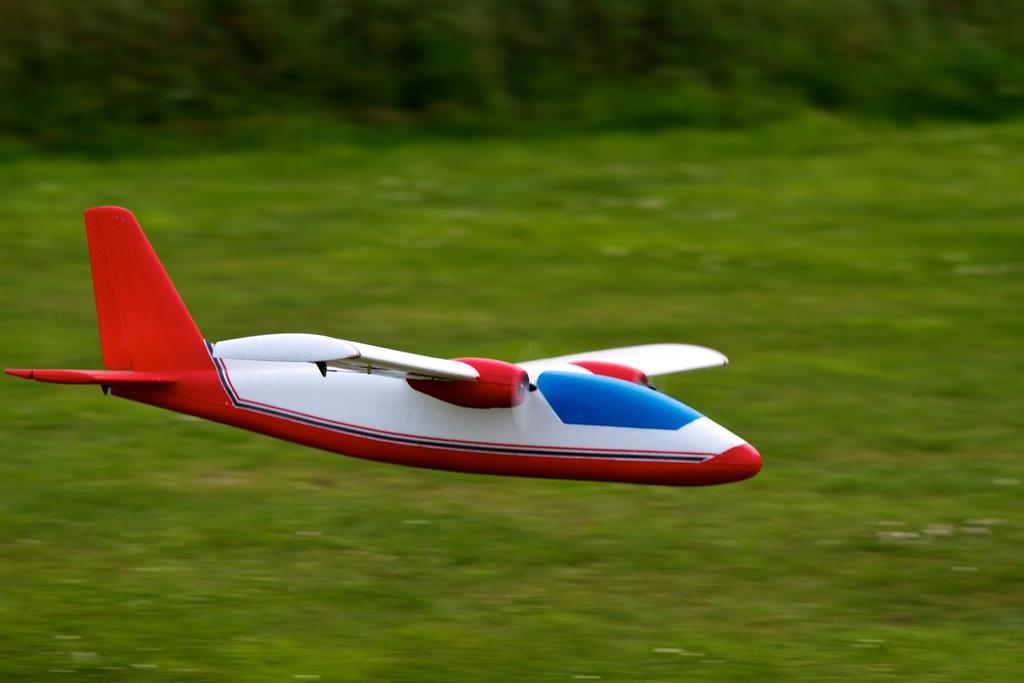In one or two sentences, can you explain what this image depicts? In this picture we can see a toy airplane flying in the air and behind the airplane there are trees. 